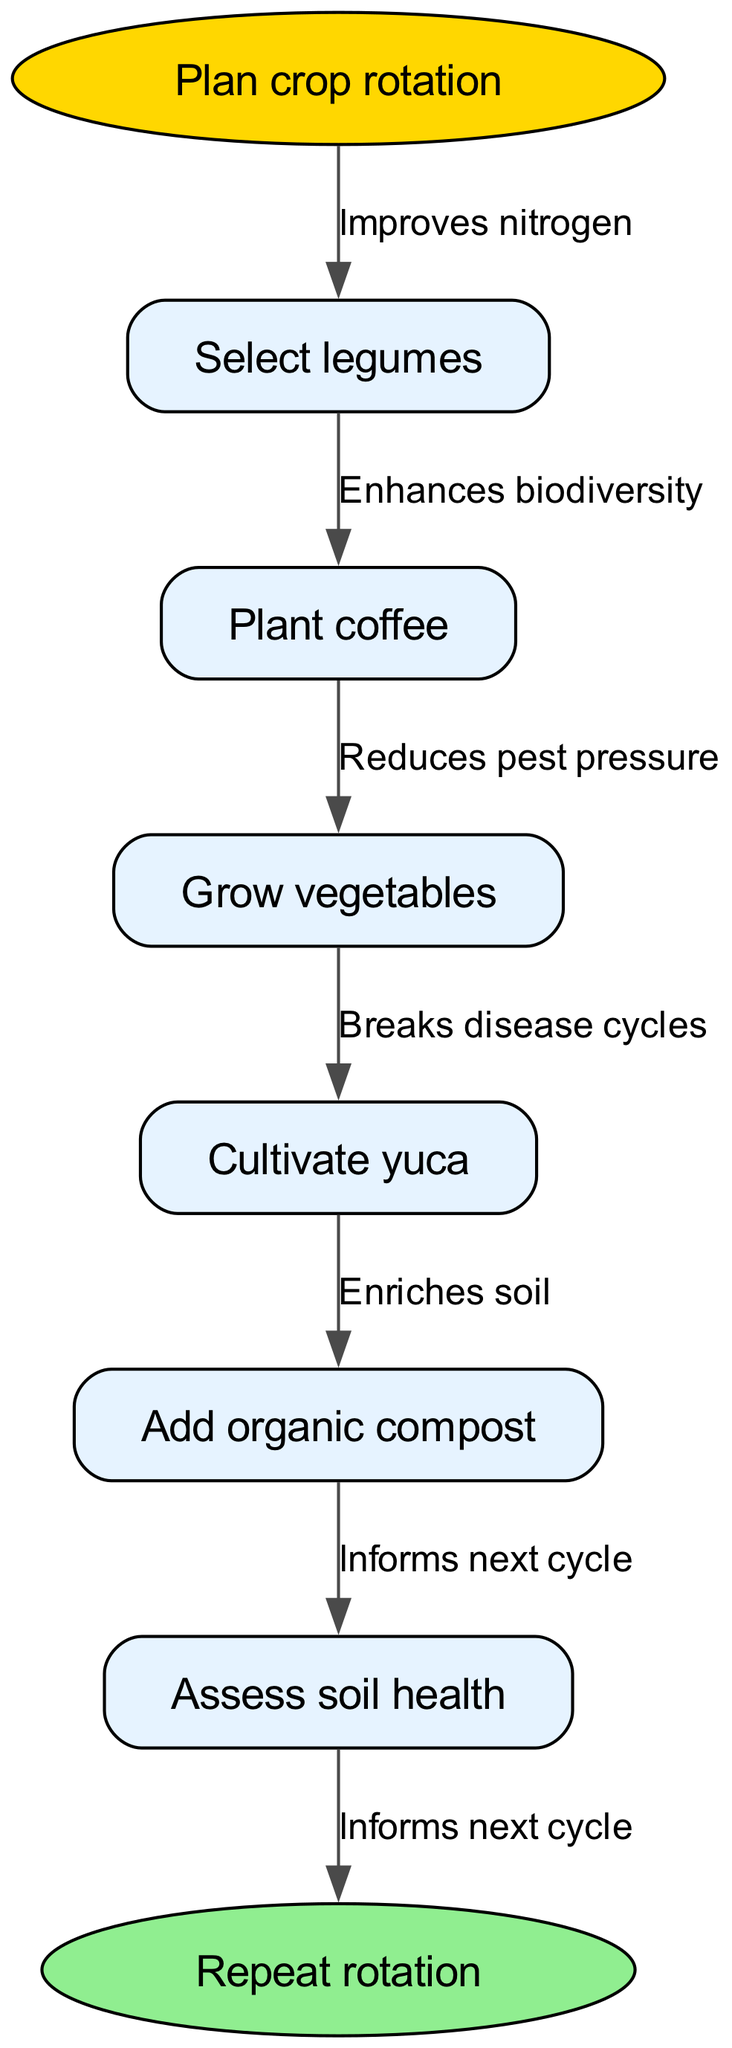What is the first step in the crop rotation cycle? The first step indicated in the diagram is "Plan crop rotation". This is noted as the starting point of the flow chart before progressing to the specific crops.
Answer: Plan crop rotation How many types of crops are included in the diagram? The diagram lists four types of crops: legumes, coffee, vegetables, and yuca. Each crop represents a node in the sequence of actions in the rotation cycle.
Answer: Four What does planting legumes improve? The diagram states that planting legumes "Improves nitrogen". This is the relationship indicated between the first crop node and its effect on soil health.
Answer: Improves nitrogen What is the purpose of adding organic compost? The edge connected to the action "Add organic compost" indicates that it "Enriches soil". This part explains the role of compost in enhancing soil nutritional value.
Answer: Enriches soil Which step informs the next cycle? The edge labeled "Informs next cycle" is connected to the node "Assess soil health". This means that this assessment provides valuable information for planning the subsequent crop rotation.
Answer: Assess soil health What step follows "Cultivate yuca"? According to the diagram flow, "Add organic compost" comes directly after "Cultivate yuca", establishing a sequence in the crop rotation process.
Answer: Add organic compost What is the final action in the crop rotation cycle? The flow chart concludes with "Repeat rotation" as the last step, indicating that the cycle is ongoing and should be performed continuously for sustainable soil management.
Answer: Repeat rotation What is associated with "Grow vegetables"? The diagram connects the action "Grow vegetables" with the edge "Reduces pest pressure", indicating the beneficial effect this step has on managing pest populations during the crop rotation.
Answer: Reduces pest pressure How does the crop rotation cycle enhance soil management? The diagram shows multiple benefits such as improving nitrogen, enhancing biodiversity, reducing pest pressure, and enriching soil. These collectively contribute to sustainable soil management practices.
Answer: Multiple benefits 